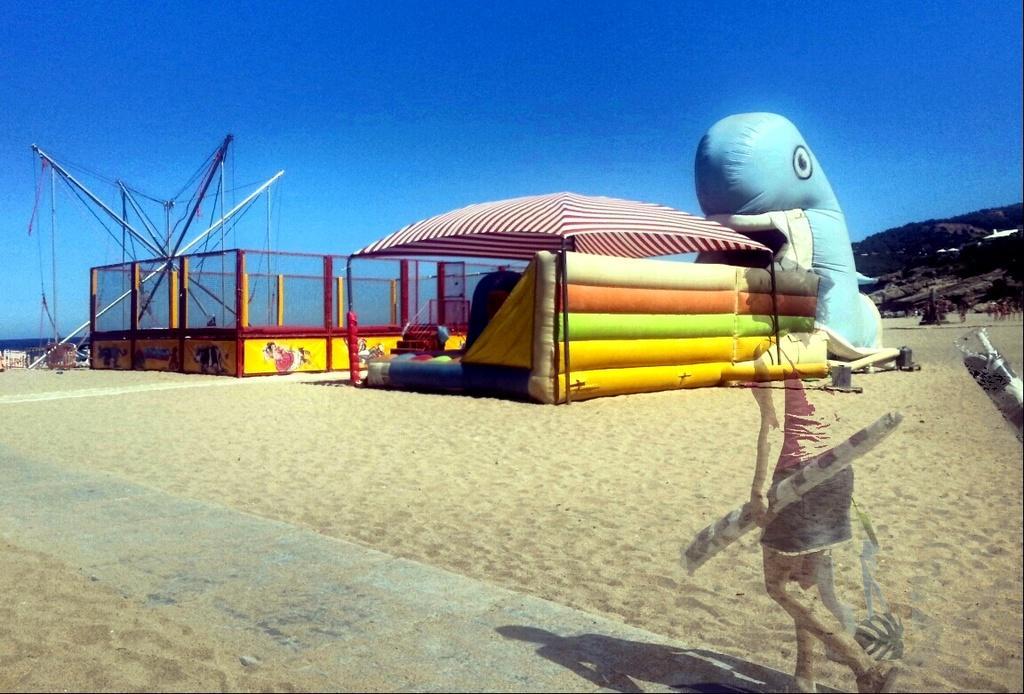In one or two sentences, can you explain what this image depicts? On the right we can see an edited image of a woman walking. In the foreground there is sand and road. In the center of the picture there are playing objects for children like balloons, tent, iron frames and other objects. In the background towards right there is a hill. At the top it is sky. 